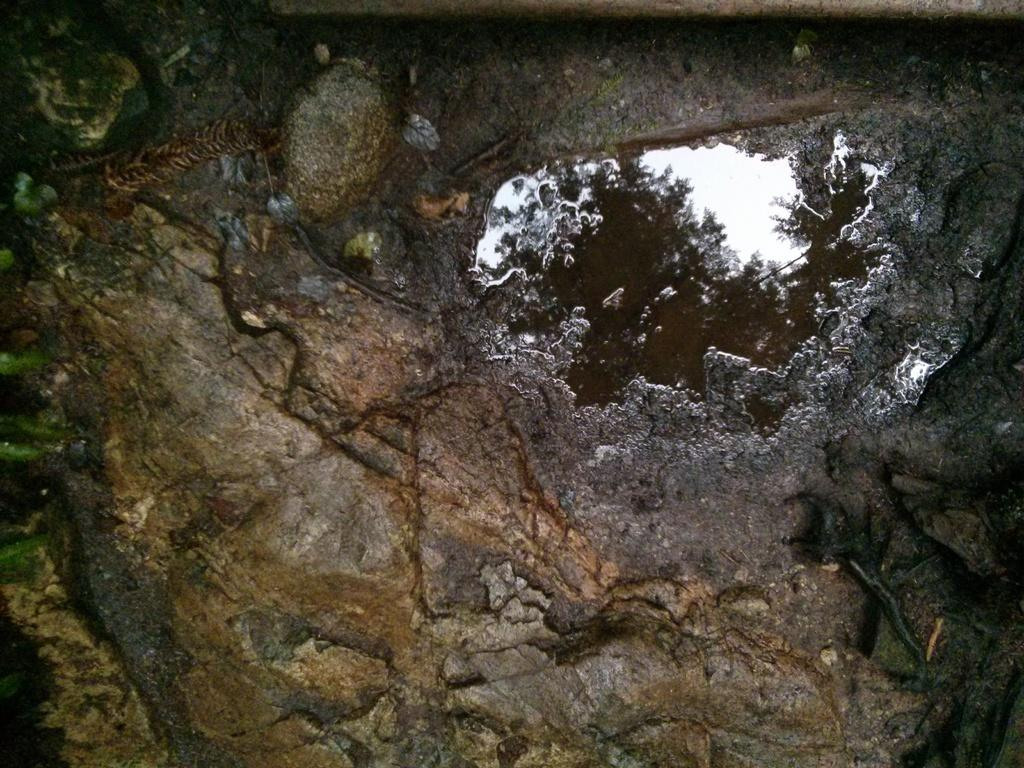What type of surface is visible in the image? The image contains the surface of a rock. What is present on the surface of the rock? There is water on the surface of the rock. What does the water reflect in the image? The water reflects a tree and the sky in the image. What type of spark can be seen coming from the truck in the image? There is no truck present in the image, so there cannot be any sparks coming from it. 